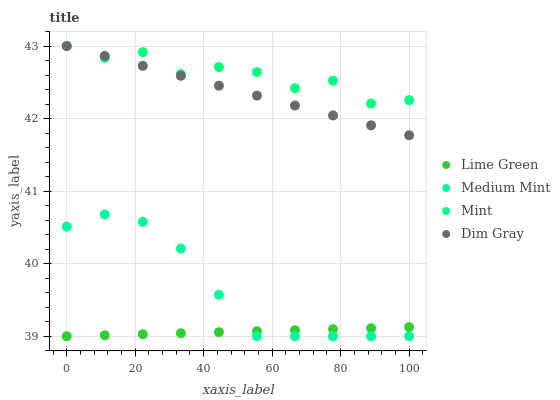Does Lime Green have the minimum area under the curve?
Answer yes or no. Yes. Does Mint have the maximum area under the curve?
Answer yes or no. Yes. Does Dim Gray have the minimum area under the curve?
Answer yes or no. No. Does Dim Gray have the maximum area under the curve?
Answer yes or no. No. Is Dim Gray the smoothest?
Answer yes or no. Yes. Is Mint the roughest?
Answer yes or no. Yes. Is Mint the smoothest?
Answer yes or no. No. Is Dim Gray the roughest?
Answer yes or no. No. Does Medium Mint have the lowest value?
Answer yes or no. Yes. Does Dim Gray have the lowest value?
Answer yes or no. No. Does Dim Gray have the highest value?
Answer yes or no. Yes. Does Lime Green have the highest value?
Answer yes or no. No. Is Medium Mint less than Mint?
Answer yes or no. Yes. Is Mint greater than Medium Mint?
Answer yes or no. Yes. Does Medium Mint intersect Lime Green?
Answer yes or no. Yes. Is Medium Mint less than Lime Green?
Answer yes or no. No. Is Medium Mint greater than Lime Green?
Answer yes or no. No. Does Medium Mint intersect Mint?
Answer yes or no. No. 